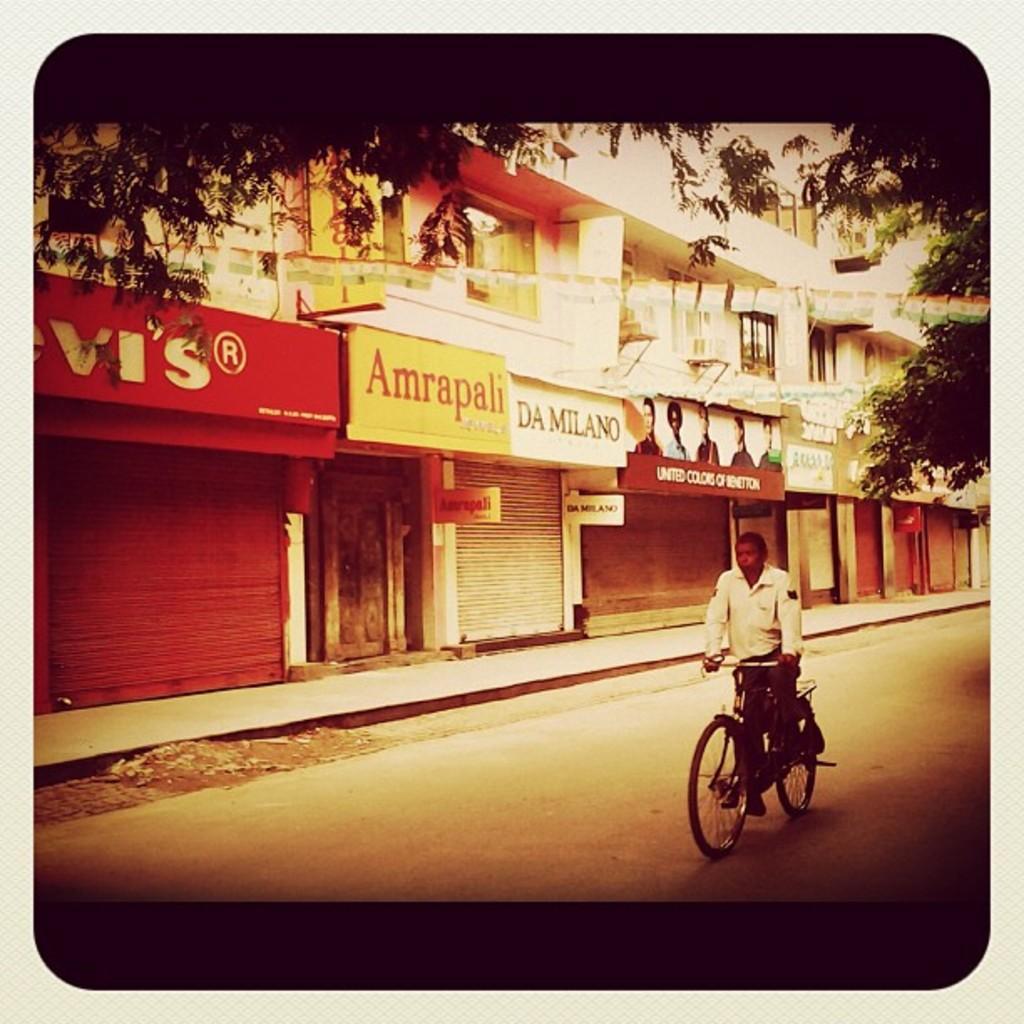Please provide a concise description of this image. In this image we can see a person riding a bicycle. In the background there are buildings and boards. At the top there are trees and we can see flags. 